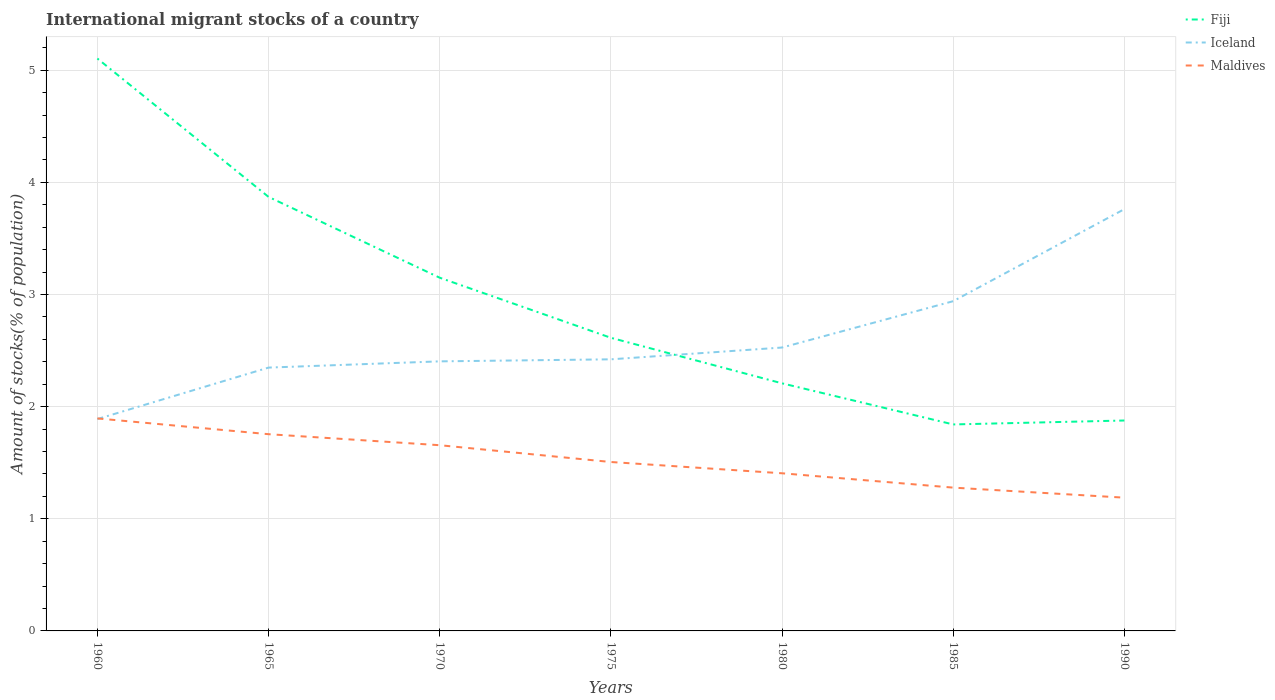How many different coloured lines are there?
Your answer should be compact. 3. Is the number of lines equal to the number of legend labels?
Offer a very short reply. Yes. Across all years, what is the maximum amount of stocks in in Iceland?
Give a very brief answer. 1.89. In which year was the amount of stocks in in Iceland maximum?
Provide a succinct answer. 1960. What is the total amount of stocks in in Maldives in the graph?
Your answer should be compact. 0.38. What is the difference between the highest and the second highest amount of stocks in in Maldives?
Provide a short and direct response. 0.71. How many years are there in the graph?
Give a very brief answer. 7. Are the values on the major ticks of Y-axis written in scientific E-notation?
Your answer should be very brief. No. Does the graph contain any zero values?
Your response must be concise. No. Does the graph contain grids?
Offer a very short reply. Yes. Where does the legend appear in the graph?
Give a very brief answer. Top right. How are the legend labels stacked?
Your response must be concise. Vertical. What is the title of the graph?
Provide a short and direct response. International migrant stocks of a country. What is the label or title of the Y-axis?
Offer a very short reply. Amount of stocks(% of population). What is the Amount of stocks(% of population) of Fiji in 1960?
Offer a terse response. 5.1. What is the Amount of stocks(% of population) of Iceland in 1960?
Offer a very short reply. 1.89. What is the Amount of stocks(% of population) of Maldives in 1960?
Your answer should be compact. 1.89. What is the Amount of stocks(% of population) in Fiji in 1965?
Keep it short and to the point. 3.87. What is the Amount of stocks(% of population) in Iceland in 1965?
Offer a terse response. 2.35. What is the Amount of stocks(% of population) of Maldives in 1965?
Provide a succinct answer. 1.75. What is the Amount of stocks(% of population) in Fiji in 1970?
Provide a short and direct response. 3.15. What is the Amount of stocks(% of population) in Iceland in 1970?
Keep it short and to the point. 2.4. What is the Amount of stocks(% of population) of Maldives in 1970?
Keep it short and to the point. 1.66. What is the Amount of stocks(% of population) of Fiji in 1975?
Provide a succinct answer. 2.61. What is the Amount of stocks(% of population) in Iceland in 1975?
Offer a very short reply. 2.42. What is the Amount of stocks(% of population) in Maldives in 1975?
Your answer should be very brief. 1.51. What is the Amount of stocks(% of population) in Fiji in 1980?
Offer a terse response. 2.21. What is the Amount of stocks(% of population) of Iceland in 1980?
Ensure brevity in your answer.  2.53. What is the Amount of stocks(% of population) of Maldives in 1980?
Provide a succinct answer. 1.41. What is the Amount of stocks(% of population) in Fiji in 1985?
Offer a very short reply. 1.84. What is the Amount of stocks(% of population) of Iceland in 1985?
Keep it short and to the point. 2.94. What is the Amount of stocks(% of population) in Maldives in 1985?
Your answer should be very brief. 1.28. What is the Amount of stocks(% of population) in Fiji in 1990?
Provide a succinct answer. 1.88. What is the Amount of stocks(% of population) of Iceland in 1990?
Your answer should be very brief. 3.76. What is the Amount of stocks(% of population) in Maldives in 1990?
Offer a terse response. 1.19. Across all years, what is the maximum Amount of stocks(% of population) of Fiji?
Ensure brevity in your answer.  5.1. Across all years, what is the maximum Amount of stocks(% of population) in Iceland?
Provide a succinct answer. 3.76. Across all years, what is the maximum Amount of stocks(% of population) of Maldives?
Your response must be concise. 1.89. Across all years, what is the minimum Amount of stocks(% of population) of Fiji?
Your answer should be compact. 1.84. Across all years, what is the minimum Amount of stocks(% of population) in Iceland?
Offer a very short reply. 1.89. Across all years, what is the minimum Amount of stocks(% of population) in Maldives?
Make the answer very short. 1.19. What is the total Amount of stocks(% of population) of Fiji in the graph?
Offer a terse response. 20.66. What is the total Amount of stocks(% of population) of Iceland in the graph?
Your answer should be compact. 18.29. What is the total Amount of stocks(% of population) of Maldives in the graph?
Give a very brief answer. 10.68. What is the difference between the Amount of stocks(% of population) of Fiji in 1960 and that in 1965?
Ensure brevity in your answer.  1.23. What is the difference between the Amount of stocks(% of population) in Iceland in 1960 and that in 1965?
Offer a terse response. -0.46. What is the difference between the Amount of stocks(% of population) of Maldives in 1960 and that in 1965?
Your response must be concise. 0.14. What is the difference between the Amount of stocks(% of population) of Fiji in 1960 and that in 1970?
Offer a very short reply. 1.95. What is the difference between the Amount of stocks(% of population) in Iceland in 1960 and that in 1970?
Your answer should be compact. -0.51. What is the difference between the Amount of stocks(% of population) in Maldives in 1960 and that in 1970?
Ensure brevity in your answer.  0.24. What is the difference between the Amount of stocks(% of population) in Fiji in 1960 and that in 1975?
Your answer should be very brief. 2.49. What is the difference between the Amount of stocks(% of population) of Iceland in 1960 and that in 1975?
Your answer should be compact. -0.53. What is the difference between the Amount of stocks(% of population) in Maldives in 1960 and that in 1975?
Your response must be concise. 0.39. What is the difference between the Amount of stocks(% of population) of Fiji in 1960 and that in 1980?
Make the answer very short. 2.9. What is the difference between the Amount of stocks(% of population) in Iceland in 1960 and that in 1980?
Ensure brevity in your answer.  -0.64. What is the difference between the Amount of stocks(% of population) of Maldives in 1960 and that in 1980?
Provide a short and direct response. 0.49. What is the difference between the Amount of stocks(% of population) of Fiji in 1960 and that in 1985?
Offer a very short reply. 3.26. What is the difference between the Amount of stocks(% of population) in Iceland in 1960 and that in 1985?
Provide a succinct answer. -1.05. What is the difference between the Amount of stocks(% of population) of Maldives in 1960 and that in 1985?
Offer a very short reply. 0.62. What is the difference between the Amount of stocks(% of population) in Fiji in 1960 and that in 1990?
Provide a succinct answer. 3.23. What is the difference between the Amount of stocks(% of population) in Iceland in 1960 and that in 1990?
Your answer should be very brief. -1.87. What is the difference between the Amount of stocks(% of population) of Maldives in 1960 and that in 1990?
Offer a very short reply. 0.71. What is the difference between the Amount of stocks(% of population) of Fiji in 1965 and that in 1970?
Offer a very short reply. 0.72. What is the difference between the Amount of stocks(% of population) of Iceland in 1965 and that in 1970?
Offer a terse response. -0.06. What is the difference between the Amount of stocks(% of population) of Maldives in 1965 and that in 1970?
Offer a very short reply. 0.1. What is the difference between the Amount of stocks(% of population) of Fiji in 1965 and that in 1975?
Your response must be concise. 1.26. What is the difference between the Amount of stocks(% of population) in Iceland in 1965 and that in 1975?
Make the answer very short. -0.07. What is the difference between the Amount of stocks(% of population) in Maldives in 1965 and that in 1975?
Keep it short and to the point. 0.25. What is the difference between the Amount of stocks(% of population) in Fiji in 1965 and that in 1980?
Give a very brief answer. 1.66. What is the difference between the Amount of stocks(% of population) of Iceland in 1965 and that in 1980?
Make the answer very short. -0.18. What is the difference between the Amount of stocks(% of population) in Maldives in 1965 and that in 1980?
Keep it short and to the point. 0.35. What is the difference between the Amount of stocks(% of population) of Fiji in 1965 and that in 1985?
Your answer should be very brief. 2.03. What is the difference between the Amount of stocks(% of population) of Iceland in 1965 and that in 1985?
Keep it short and to the point. -0.59. What is the difference between the Amount of stocks(% of population) of Maldives in 1965 and that in 1985?
Keep it short and to the point. 0.48. What is the difference between the Amount of stocks(% of population) in Fiji in 1965 and that in 1990?
Give a very brief answer. 1.99. What is the difference between the Amount of stocks(% of population) of Iceland in 1965 and that in 1990?
Keep it short and to the point. -1.41. What is the difference between the Amount of stocks(% of population) in Maldives in 1965 and that in 1990?
Provide a succinct answer. 0.57. What is the difference between the Amount of stocks(% of population) in Fiji in 1970 and that in 1975?
Offer a very short reply. 0.54. What is the difference between the Amount of stocks(% of population) in Iceland in 1970 and that in 1975?
Provide a short and direct response. -0.02. What is the difference between the Amount of stocks(% of population) of Maldives in 1970 and that in 1975?
Keep it short and to the point. 0.15. What is the difference between the Amount of stocks(% of population) in Fiji in 1970 and that in 1980?
Your answer should be compact. 0.94. What is the difference between the Amount of stocks(% of population) of Iceland in 1970 and that in 1980?
Offer a terse response. -0.12. What is the difference between the Amount of stocks(% of population) in Maldives in 1970 and that in 1980?
Make the answer very short. 0.25. What is the difference between the Amount of stocks(% of population) of Fiji in 1970 and that in 1985?
Offer a terse response. 1.31. What is the difference between the Amount of stocks(% of population) in Iceland in 1970 and that in 1985?
Your answer should be compact. -0.54. What is the difference between the Amount of stocks(% of population) of Maldives in 1970 and that in 1985?
Your answer should be very brief. 0.38. What is the difference between the Amount of stocks(% of population) in Fiji in 1970 and that in 1990?
Give a very brief answer. 1.27. What is the difference between the Amount of stocks(% of population) in Iceland in 1970 and that in 1990?
Your answer should be compact. -1.36. What is the difference between the Amount of stocks(% of population) of Maldives in 1970 and that in 1990?
Keep it short and to the point. 0.47. What is the difference between the Amount of stocks(% of population) in Fiji in 1975 and that in 1980?
Your answer should be compact. 0.41. What is the difference between the Amount of stocks(% of population) of Iceland in 1975 and that in 1980?
Make the answer very short. -0.11. What is the difference between the Amount of stocks(% of population) in Maldives in 1975 and that in 1980?
Your answer should be compact. 0.1. What is the difference between the Amount of stocks(% of population) of Fiji in 1975 and that in 1985?
Offer a very short reply. 0.77. What is the difference between the Amount of stocks(% of population) in Iceland in 1975 and that in 1985?
Your answer should be compact. -0.52. What is the difference between the Amount of stocks(% of population) of Maldives in 1975 and that in 1985?
Provide a succinct answer. 0.23. What is the difference between the Amount of stocks(% of population) in Fiji in 1975 and that in 1990?
Offer a terse response. 0.74. What is the difference between the Amount of stocks(% of population) in Iceland in 1975 and that in 1990?
Your answer should be very brief. -1.34. What is the difference between the Amount of stocks(% of population) in Maldives in 1975 and that in 1990?
Make the answer very short. 0.32. What is the difference between the Amount of stocks(% of population) in Fiji in 1980 and that in 1985?
Your response must be concise. 0.37. What is the difference between the Amount of stocks(% of population) of Iceland in 1980 and that in 1985?
Keep it short and to the point. -0.41. What is the difference between the Amount of stocks(% of population) in Maldives in 1980 and that in 1985?
Keep it short and to the point. 0.13. What is the difference between the Amount of stocks(% of population) of Fiji in 1980 and that in 1990?
Provide a short and direct response. 0.33. What is the difference between the Amount of stocks(% of population) of Iceland in 1980 and that in 1990?
Your answer should be compact. -1.23. What is the difference between the Amount of stocks(% of population) in Maldives in 1980 and that in 1990?
Make the answer very short. 0.22. What is the difference between the Amount of stocks(% of population) in Fiji in 1985 and that in 1990?
Make the answer very short. -0.04. What is the difference between the Amount of stocks(% of population) in Iceland in 1985 and that in 1990?
Provide a succinct answer. -0.82. What is the difference between the Amount of stocks(% of population) in Maldives in 1985 and that in 1990?
Ensure brevity in your answer.  0.09. What is the difference between the Amount of stocks(% of population) of Fiji in 1960 and the Amount of stocks(% of population) of Iceland in 1965?
Keep it short and to the point. 2.76. What is the difference between the Amount of stocks(% of population) of Fiji in 1960 and the Amount of stocks(% of population) of Maldives in 1965?
Ensure brevity in your answer.  3.35. What is the difference between the Amount of stocks(% of population) in Iceland in 1960 and the Amount of stocks(% of population) in Maldives in 1965?
Offer a terse response. 0.14. What is the difference between the Amount of stocks(% of population) in Fiji in 1960 and the Amount of stocks(% of population) in Iceland in 1970?
Your answer should be compact. 2.7. What is the difference between the Amount of stocks(% of population) of Fiji in 1960 and the Amount of stocks(% of population) of Maldives in 1970?
Provide a short and direct response. 3.45. What is the difference between the Amount of stocks(% of population) in Iceland in 1960 and the Amount of stocks(% of population) in Maldives in 1970?
Give a very brief answer. 0.23. What is the difference between the Amount of stocks(% of population) in Fiji in 1960 and the Amount of stocks(% of population) in Iceland in 1975?
Your response must be concise. 2.68. What is the difference between the Amount of stocks(% of population) of Fiji in 1960 and the Amount of stocks(% of population) of Maldives in 1975?
Ensure brevity in your answer.  3.6. What is the difference between the Amount of stocks(% of population) of Iceland in 1960 and the Amount of stocks(% of population) of Maldives in 1975?
Ensure brevity in your answer.  0.38. What is the difference between the Amount of stocks(% of population) in Fiji in 1960 and the Amount of stocks(% of population) in Iceland in 1980?
Your response must be concise. 2.58. What is the difference between the Amount of stocks(% of population) in Fiji in 1960 and the Amount of stocks(% of population) in Maldives in 1980?
Offer a terse response. 3.7. What is the difference between the Amount of stocks(% of population) in Iceland in 1960 and the Amount of stocks(% of population) in Maldives in 1980?
Offer a terse response. 0.48. What is the difference between the Amount of stocks(% of population) of Fiji in 1960 and the Amount of stocks(% of population) of Iceland in 1985?
Offer a terse response. 2.16. What is the difference between the Amount of stocks(% of population) in Fiji in 1960 and the Amount of stocks(% of population) in Maldives in 1985?
Offer a very short reply. 3.83. What is the difference between the Amount of stocks(% of population) in Iceland in 1960 and the Amount of stocks(% of population) in Maldives in 1985?
Offer a terse response. 0.61. What is the difference between the Amount of stocks(% of population) of Fiji in 1960 and the Amount of stocks(% of population) of Iceland in 1990?
Your answer should be compact. 1.34. What is the difference between the Amount of stocks(% of population) in Fiji in 1960 and the Amount of stocks(% of population) in Maldives in 1990?
Your answer should be very brief. 3.92. What is the difference between the Amount of stocks(% of population) of Iceland in 1960 and the Amount of stocks(% of population) of Maldives in 1990?
Provide a short and direct response. 0.7. What is the difference between the Amount of stocks(% of population) in Fiji in 1965 and the Amount of stocks(% of population) in Iceland in 1970?
Keep it short and to the point. 1.47. What is the difference between the Amount of stocks(% of population) of Fiji in 1965 and the Amount of stocks(% of population) of Maldives in 1970?
Keep it short and to the point. 2.21. What is the difference between the Amount of stocks(% of population) of Iceland in 1965 and the Amount of stocks(% of population) of Maldives in 1970?
Your answer should be very brief. 0.69. What is the difference between the Amount of stocks(% of population) in Fiji in 1965 and the Amount of stocks(% of population) in Iceland in 1975?
Ensure brevity in your answer.  1.45. What is the difference between the Amount of stocks(% of population) in Fiji in 1965 and the Amount of stocks(% of population) in Maldives in 1975?
Keep it short and to the point. 2.36. What is the difference between the Amount of stocks(% of population) of Iceland in 1965 and the Amount of stocks(% of population) of Maldives in 1975?
Offer a very short reply. 0.84. What is the difference between the Amount of stocks(% of population) of Fiji in 1965 and the Amount of stocks(% of population) of Iceland in 1980?
Provide a succinct answer. 1.34. What is the difference between the Amount of stocks(% of population) in Fiji in 1965 and the Amount of stocks(% of population) in Maldives in 1980?
Provide a succinct answer. 2.46. What is the difference between the Amount of stocks(% of population) in Iceland in 1965 and the Amount of stocks(% of population) in Maldives in 1980?
Your answer should be compact. 0.94. What is the difference between the Amount of stocks(% of population) in Fiji in 1965 and the Amount of stocks(% of population) in Iceland in 1985?
Ensure brevity in your answer.  0.93. What is the difference between the Amount of stocks(% of population) in Fiji in 1965 and the Amount of stocks(% of population) in Maldives in 1985?
Provide a succinct answer. 2.59. What is the difference between the Amount of stocks(% of population) of Iceland in 1965 and the Amount of stocks(% of population) of Maldives in 1985?
Your answer should be compact. 1.07. What is the difference between the Amount of stocks(% of population) in Fiji in 1965 and the Amount of stocks(% of population) in Iceland in 1990?
Your answer should be very brief. 0.11. What is the difference between the Amount of stocks(% of population) of Fiji in 1965 and the Amount of stocks(% of population) of Maldives in 1990?
Provide a short and direct response. 2.68. What is the difference between the Amount of stocks(% of population) of Iceland in 1965 and the Amount of stocks(% of population) of Maldives in 1990?
Give a very brief answer. 1.16. What is the difference between the Amount of stocks(% of population) in Fiji in 1970 and the Amount of stocks(% of population) in Iceland in 1975?
Your answer should be very brief. 0.73. What is the difference between the Amount of stocks(% of population) in Fiji in 1970 and the Amount of stocks(% of population) in Maldives in 1975?
Give a very brief answer. 1.64. What is the difference between the Amount of stocks(% of population) in Iceland in 1970 and the Amount of stocks(% of population) in Maldives in 1975?
Ensure brevity in your answer.  0.9. What is the difference between the Amount of stocks(% of population) in Fiji in 1970 and the Amount of stocks(% of population) in Iceland in 1980?
Provide a succinct answer. 0.62. What is the difference between the Amount of stocks(% of population) of Fiji in 1970 and the Amount of stocks(% of population) of Maldives in 1980?
Offer a terse response. 1.74. What is the difference between the Amount of stocks(% of population) of Fiji in 1970 and the Amount of stocks(% of population) of Iceland in 1985?
Your answer should be compact. 0.21. What is the difference between the Amount of stocks(% of population) of Fiji in 1970 and the Amount of stocks(% of population) of Maldives in 1985?
Keep it short and to the point. 1.87. What is the difference between the Amount of stocks(% of population) of Iceland in 1970 and the Amount of stocks(% of population) of Maldives in 1985?
Give a very brief answer. 1.13. What is the difference between the Amount of stocks(% of population) in Fiji in 1970 and the Amount of stocks(% of population) in Iceland in 1990?
Provide a short and direct response. -0.61. What is the difference between the Amount of stocks(% of population) of Fiji in 1970 and the Amount of stocks(% of population) of Maldives in 1990?
Keep it short and to the point. 1.96. What is the difference between the Amount of stocks(% of population) in Iceland in 1970 and the Amount of stocks(% of population) in Maldives in 1990?
Your response must be concise. 1.22. What is the difference between the Amount of stocks(% of population) in Fiji in 1975 and the Amount of stocks(% of population) in Iceland in 1980?
Offer a terse response. 0.09. What is the difference between the Amount of stocks(% of population) of Fiji in 1975 and the Amount of stocks(% of population) of Maldives in 1980?
Make the answer very short. 1.21. What is the difference between the Amount of stocks(% of population) in Iceland in 1975 and the Amount of stocks(% of population) in Maldives in 1980?
Provide a short and direct response. 1.02. What is the difference between the Amount of stocks(% of population) of Fiji in 1975 and the Amount of stocks(% of population) of Iceland in 1985?
Make the answer very short. -0.33. What is the difference between the Amount of stocks(% of population) in Fiji in 1975 and the Amount of stocks(% of population) in Maldives in 1985?
Offer a very short reply. 1.34. What is the difference between the Amount of stocks(% of population) in Iceland in 1975 and the Amount of stocks(% of population) in Maldives in 1985?
Make the answer very short. 1.14. What is the difference between the Amount of stocks(% of population) in Fiji in 1975 and the Amount of stocks(% of population) in Iceland in 1990?
Ensure brevity in your answer.  -1.15. What is the difference between the Amount of stocks(% of population) in Fiji in 1975 and the Amount of stocks(% of population) in Maldives in 1990?
Keep it short and to the point. 1.43. What is the difference between the Amount of stocks(% of population) in Iceland in 1975 and the Amount of stocks(% of population) in Maldives in 1990?
Offer a very short reply. 1.23. What is the difference between the Amount of stocks(% of population) in Fiji in 1980 and the Amount of stocks(% of population) in Iceland in 1985?
Provide a succinct answer. -0.73. What is the difference between the Amount of stocks(% of population) in Fiji in 1980 and the Amount of stocks(% of population) in Maldives in 1985?
Provide a succinct answer. 0.93. What is the difference between the Amount of stocks(% of population) of Iceland in 1980 and the Amount of stocks(% of population) of Maldives in 1985?
Provide a short and direct response. 1.25. What is the difference between the Amount of stocks(% of population) of Fiji in 1980 and the Amount of stocks(% of population) of Iceland in 1990?
Offer a terse response. -1.55. What is the difference between the Amount of stocks(% of population) of Fiji in 1980 and the Amount of stocks(% of population) of Maldives in 1990?
Ensure brevity in your answer.  1.02. What is the difference between the Amount of stocks(% of population) of Iceland in 1980 and the Amount of stocks(% of population) of Maldives in 1990?
Ensure brevity in your answer.  1.34. What is the difference between the Amount of stocks(% of population) in Fiji in 1985 and the Amount of stocks(% of population) in Iceland in 1990?
Keep it short and to the point. -1.92. What is the difference between the Amount of stocks(% of population) of Fiji in 1985 and the Amount of stocks(% of population) of Maldives in 1990?
Provide a succinct answer. 0.65. What is the difference between the Amount of stocks(% of population) in Iceland in 1985 and the Amount of stocks(% of population) in Maldives in 1990?
Ensure brevity in your answer.  1.75. What is the average Amount of stocks(% of population) of Fiji per year?
Offer a terse response. 2.95. What is the average Amount of stocks(% of population) in Iceland per year?
Make the answer very short. 2.61. What is the average Amount of stocks(% of population) in Maldives per year?
Your answer should be compact. 1.53. In the year 1960, what is the difference between the Amount of stocks(% of population) of Fiji and Amount of stocks(% of population) of Iceland?
Provide a succinct answer. 3.21. In the year 1960, what is the difference between the Amount of stocks(% of population) in Fiji and Amount of stocks(% of population) in Maldives?
Offer a terse response. 3.21. In the year 1960, what is the difference between the Amount of stocks(% of population) of Iceland and Amount of stocks(% of population) of Maldives?
Keep it short and to the point. -0.01. In the year 1965, what is the difference between the Amount of stocks(% of population) in Fiji and Amount of stocks(% of population) in Iceland?
Provide a short and direct response. 1.52. In the year 1965, what is the difference between the Amount of stocks(% of population) in Fiji and Amount of stocks(% of population) in Maldives?
Give a very brief answer. 2.12. In the year 1965, what is the difference between the Amount of stocks(% of population) in Iceland and Amount of stocks(% of population) in Maldives?
Offer a very short reply. 0.59. In the year 1970, what is the difference between the Amount of stocks(% of population) in Fiji and Amount of stocks(% of population) in Iceland?
Keep it short and to the point. 0.75. In the year 1970, what is the difference between the Amount of stocks(% of population) in Fiji and Amount of stocks(% of population) in Maldives?
Provide a short and direct response. 1.49. In the year 1970, what is the difference between the Amount of stocks(% of population) in Iceland and Amount of stocks(% of population) in Maldives?
Give a very brief answer. 0.75. In the year 1975, what is the difference between the Amount of stocks(% of population) of Fiji and Amount of stocks(% of population) of Iceland?
Offer a very short reply. 0.19. In the year 1975, what is the difference between the Amount of stocks(% of population) in Fiji and Amount of stocks(% of population) in Maldives?
Your answer should be compact. 1.11. In the year 1975, what is the difference between the Amount of stocks(% of population) of Iceland and Amount of stocks(% of population) of Maldives?
Give a very brief answer. 0.92. In the year 1980, what is the difference between the Amount of stocks(% of population) in Fiji and Amount of stocks(% of population) in Iceland?
Keep it short and to the point. -0.32. In the year 1980, what is the difference between the Amount of stocks(% of population) in Fiji and Amount of stocks(% of population) in Maldives?
Offer a very short reply. 0.8. In the year 1980, what is the difference between the Amount of stocks(% of population) in Iceland and Amount of stocks(% of population) in Maldives?
Your answer should be compact. 1.12. In the year 1985, what is the difference between the Amount of stocks(% of population) in Fiji and Amount of stocks(% of population) in Iceland?
Give a very brief answer. -1.1. In the year 1985, what is the difference between the Amount of stocks(% of population) of Fiji and Amount of stocks(% of population) of Maldives?
Provide a short and direct response. 0.56. In the year 1985, what is the difference between the Amount of stocks(% of population) of Iceland and Amount of stocks(% of population) of Maldives?
Your response must be concise. 1.66. In the year 1990, what is the difference between the Amount of stocks(% of population) in Fiji and Amount of stocks(% of population) in Iceland?
Offer a very short reply. -1.88. In the year 1990, what is the difference between the Amount of stocks(% of population) of Fiji and Amount of stocks(% of population) of Maldives?
Your answer should be very brief. 0.69. In the year 1990, what is the difference between the Amount of stocks(% of population) in Iceland and Amount of stocks(% of population) in Maldives?
Make the answer very short. 2.57. What is the ratio of the Amount of stocks(% of population) of Fiji in 1960 to that in 1965?
Ensure brevity in your answer.  1.32. What is the ratio of the Amount of stocks(% of population) in Iceland in 1960 to that in 1965?
Keep it short and to the point. 0.8. What is the ratio of the Amount of stocks(% of population) of Maldives in 1960 to that in 1965?
Offer a terse response. 1.08. What is the ratio of the Amount of stocks(% of population) in Fiji in 1960 to that in 1970?
Ensure brevity in your answer.  1.62. What is the ratio of the Amount of stocks(% of population) in Iceland in 1960 to that in 1970?
Make the answer very short. 0.79. What is the ratio of the Amount of stocks(% of population) in Maldives in 1960 to that in 1970?
Your response must be concise. 1.14. What is the ratio of the Amount of stocks(% of population) of Fiji in 1960 to that in 1975?
Your response must be concise. 1.95. What is the ratio of the Amount of stocks(% of population) in Iceland in 1960 to that in 1975?
Provide a succinct answer. 0.78. What is the ratio of the Amount of stocks(% of population) of Maldives in 1960 to that in 1975?
Your response must be concise. 1.26. What is the ratio of the Amount of stocks(% of population) in Fiji in 1960 to that in 1980?
Your answer should be very brief. 2.31. What is the ratio of the Amount of stocks(% of population) in Iceland in 1960 to that in 1980?
Your answer should be compact. 0.75. What is the ratio of the Amount of stocks(% of population) of Maldives in 1960 to that in 1980?
Offer a very short reply. 1.35. What is the ratio of the Amount of stocks(% of population) of Fiji in 1960 to that in 1985?
Your answer should be very brief. 2.77. What is the ratio of the Amount of stocks(% of population) in Iceland in 1960 to that in 1985?
Provide a short and direct response. 0.64. What is the ratio of the Amount of stocks(% of population) in Maldives in 1960 to that in 1985?
Provide a succinct answer. 1.48. What is the ratio of the Amount of stocks(% of population) of Fiji in 1960 to that in 1990?
Give a very brief answer. 2.72. What is the ratio of the Amount of stocks(% of population) of Iceland in 1960 to that in 1990?
Make the answer very short. 0.5. What is the ratio of the Amount of stocks(% of population) in Maldives in 1960 to that in 1990?
Provide a succinct answer. 1.59. What is the ratio of the Amount of stocks(% of population) of Fiji in 1965 to that in 1970?
Ensure brevity in your answer.  1.23. What is the ratio of the Amount of stocks(% of population) in Iceland in 1965 to that in 1970?
Make the answer very short. 0.98. What is the ratio of the Amount of stocks(% of population) of Maldives in 1965 to that in 1970?
Offer a terse response. 1.06. What is the ratio of the Amount of stocks(% of population) in Fiji in 1965 to that in 1975?
Ensure brevity in your answer.  1.48. What is the ratio of the Amount of stocks(% of population) in Iceland in 1965 to that in 1975?
Offer a very short reply. 0.97. What is the ratio of the Amount of stocks(% of population) in Maldives in 1965 to that in 1975?
Your response must be concise. 1.16. What is the ratio of the Amount of stocks(% of population) of Fiji in 1965 to that in 1980?
Offer a terse response. 1.75. What is the ratio of the Amount of stocks(% of population) in Iceland in 1965 to that in 1980?
Your response must be concise. 0.93. What is the ratio of the Amount of stocks(% of population) in Maldives in 1965 to that in 1980?
Make the answer very short. 1.25. What is the ratio of the Amount of stocks(% of population) in Fiji in 1965 to that in 1985?
Offer a very short reply. 2.1. What is the ratio of the Amount of stocks(% of population) in Iceland in 1965 to that in 1985?
Offer a very short reply. 0.8. What is the ratio of the Amount of stocks(% of population) in Maldives in 1965 to that in 1985?
Give a very brief answer. 1.37. What is the ratio of the Amount of stocks(% of population) in Fiji in 1965 to that in 1990?
Your answer should be compact. 2.06. What is the ratio of the Amount of stocks(% of population) of Iceland in 1965 to that in 1990?
Your answer should be compact. 0.62. What is the ratio of the Amount of stocks(% of population) in Maldives in 1965 to that in 1990?
Your response must be concise. 1.48. What is the ratio of the Amount of stocks(% of population) of Fiji in 1970 to that in 1975?
Make the answer very short. 1.2. What is the ratio of the Amount of stocks(% of population) in Maldives in 1970 to that in 1975?
Keep it short and to the point. 1.1. What is the ratio of the Amount of stocks(% of population) in Fiji in 1970 to that in 1980?
Provide a short and direct response. 1.43. What is the ratio of the Amount of stocks(% of population) of Iceland in 1970 to that in 1980?
Ensure brevity in your answer.  0.95. What is the ratio of the Amount of stocks(% of population) in Maldives in 1970 to that in 1980?
Provide a short and direct response. 1.18. What is the ratio of the Amount of stocks(% of population) in Fiji in 1970 to that in 1985?
Provide a succinct answer. 1.71. What is the ratio of the Amount of stocks(% of population) in Iceland in 1970 to that in 1985?
Your answer should be compact. 0.82. What is the ratio of the Amount of stocks(% of population) in Maldives in 1970 to that in 1985?
Make the answer very short. 1.3. What is the ratio of the Amount of stocks(% of population) in Fiji in 1970 to that in 1990?
Provide a succinct answer. 1.68. What is the ratio of the Amount of stocks(% of population) in Iceland in 1970 to that in 1990?
Provide a short and direct response. 0.64. What is the ratio of the Amount of stocks(% of population) of Maldives in 1970 to that in 1990?
Offer a terse response. 1.39. What is the ratio of the Amount of stocks(% of population) of Fiji in 1975 to that in 1980?
Keep it short and to the point. 1.18. What is the ratio of the Amount of stocks(% of population) of Iceland in 1975 to that in 1980?
Your answer should be very brief. 0.96. What is the ratio of the Amount of stocks(% of population) of Maldives in 1975 to that in 1980?
Give a very brief answer. 1.07. What is the ratio of the Amount of stocks(% of population) of Fiji in 1975 to that in 1985?
Provide a succinct answer. 1.42. What is the ratio of the Amount of stocks(% of population) in Iceland in 1975 to that in 1985?
Your answer should be compact. 0.82. What is the ratio of the Amount of stocks(% of population) of Maldives in 1975 to that in 1985?
Offer a very short reply. 1.18. What is the ratio of the Amount of stocks(% of population) of Fiji in 1975 to that in 1990?
Provide a succinct answer. 1.39. What is the ratio of the Amount of stocks(% of population) of Iceland in 1975 to that in 1990?
Offer a very short reply. 0.64. What is the ratio of the Amount of stocks(% of population) in Maldives in 1975 to that in 1990?
Offer a very short reply. 1.27. What is the ratio of the Amount of stocks(% of population) in Fiji in 1980 to that in 1985?
Give a very brief answer. 1.2. What is the ratio of the Amount of stocks(% of population) of Iceland in 1980 to that in 1985?
Keep it short and to the point. 0.86. What is the ratio of the Amount of stocks(% of population) in Maldives in 1980 to that in 1985?
Your answer should be compact. 1.1. What is the ratio of the Amount of stocks(% of population) of Fiji in 1980 to that in 1990?
Offer a very short reply. 1.18. What is the ratio of the Amount of stocks(% of population) of Iceland in 1980 to that in 1990?
Provide a short and direct response. 0.67. What is the ratio of the Amount of stocks(% of population) of Maldives in 1980 to that in 1990?
Give a very brief answer. 1.18. What is the ratio of the Amount of stocks(% of population) of Fiji in 1985 to that in 1990?
Keep it short and to the point. 0.98. What is the ratio of the Amount of stocks(% of population) in Iceland in 1985 to that in 1990?
Give a very brief answer. 0.78. What is the ratio of the Amount of stocks(% of population) of Maldives in 1985 to that in 1990?
Your answer should be compact. 1.08. What is the difference between the highest and the second highest Amount of stocks(% of population) of Fiji?
Your answer should be compact. 1.23. What is the difference between the highest and the second highest Amount of stocks(% of population) of Iceland?
Give a very brief answer. 0.82. What is the difference between the highest and the second highest Amount of stocks(% of population) in Maldives?
Give a very brief answer. 0.14. What is the difference between the highest and the lowest Amount of stocks(% of population) in Fiji?
Your answer should be compact. 3.26. What is the difference between the highest and the lowest Amount of stocks(% of population) of Iceland?
Your response must be concise. 1.87. What is the difference between the highest and the lowest Amount of stocks(% of population) of Maldives?
Offer a terse response. 0.71. 